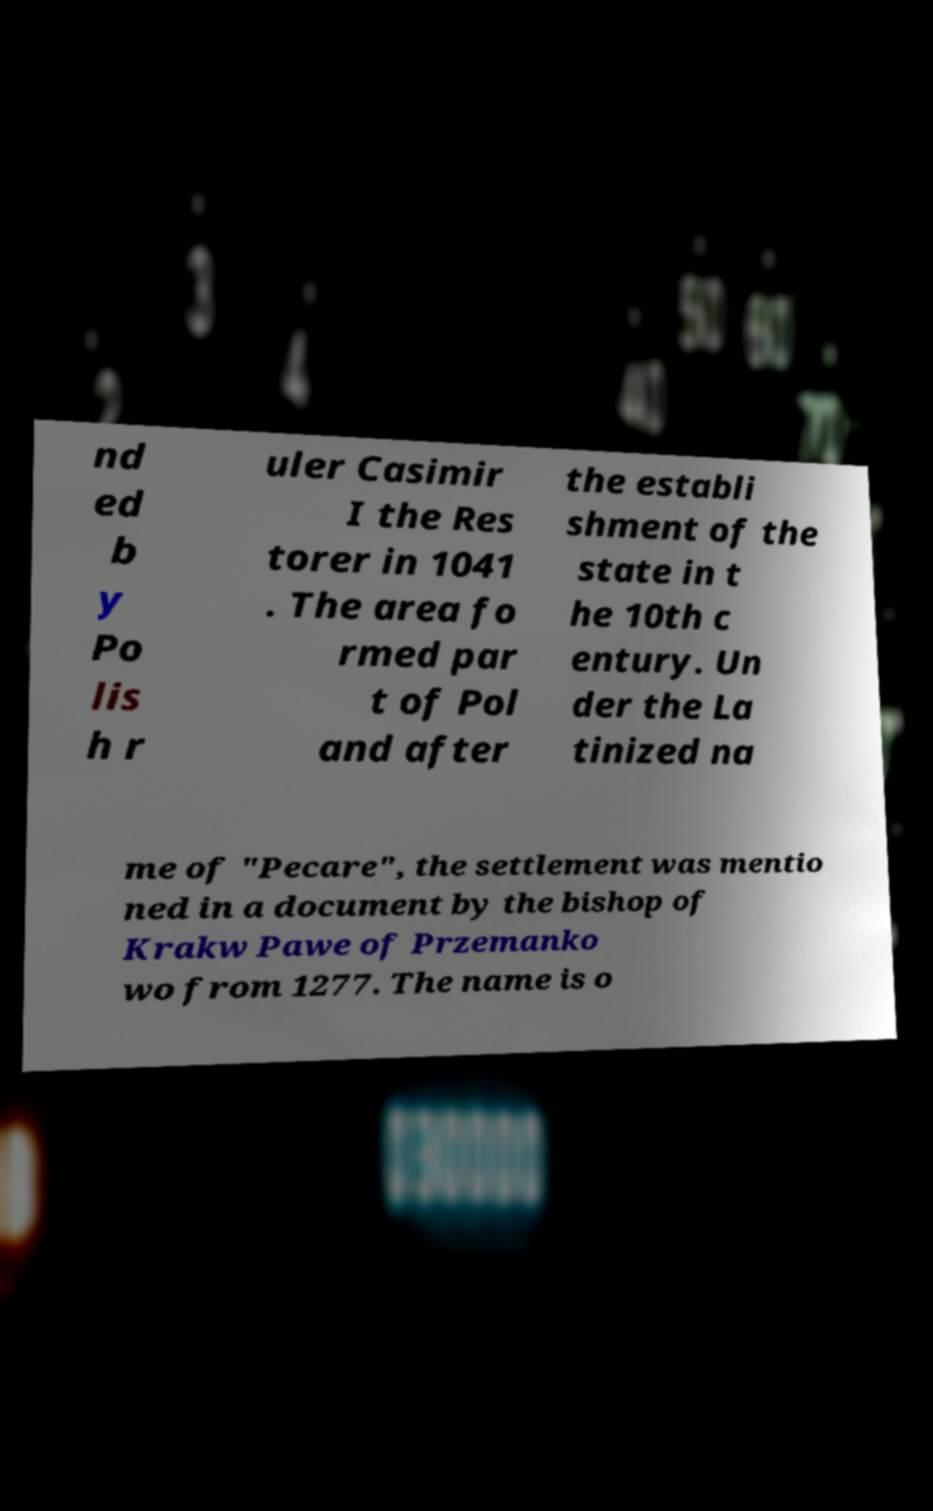I need the written content from this picture converted into text. Can you do that? nd ed b y Po lis h r uler Casimir I the Res torer in 1041 . The area fo rmed par t of Pol and after the establi shment of the state in t he 10th c entury. Un der the La tinized na me of "Pecare", the settlement was mentio ned in a document by the bishop of Krakw Pawe of Przemanko wo from 1277. The name is o 